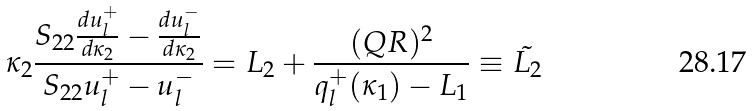Convert formula to latex. <formula><loc_0><loc_0><loc_500><loc_500>\kappa _ { 2 } \frac { S _ { 2 2 } \frac { d u _ { l } ^ { + } } { d \kappa _ { 2 } } - \frac { d u _ { l } ^ { - } } { d \kappa _ { 2 } } } { S _ { 2 2 } u _ { l } ^ { + } - u _ { l } ^ { - } } = L _ { 2 } + \frac { ( Q R ) ^ { 2 } } { q _ { l } ^ { + } ( \kappa _ { 1 } ) - L _ { 1 } } \equiv \tilde { L _ { 2 } }</formula> 